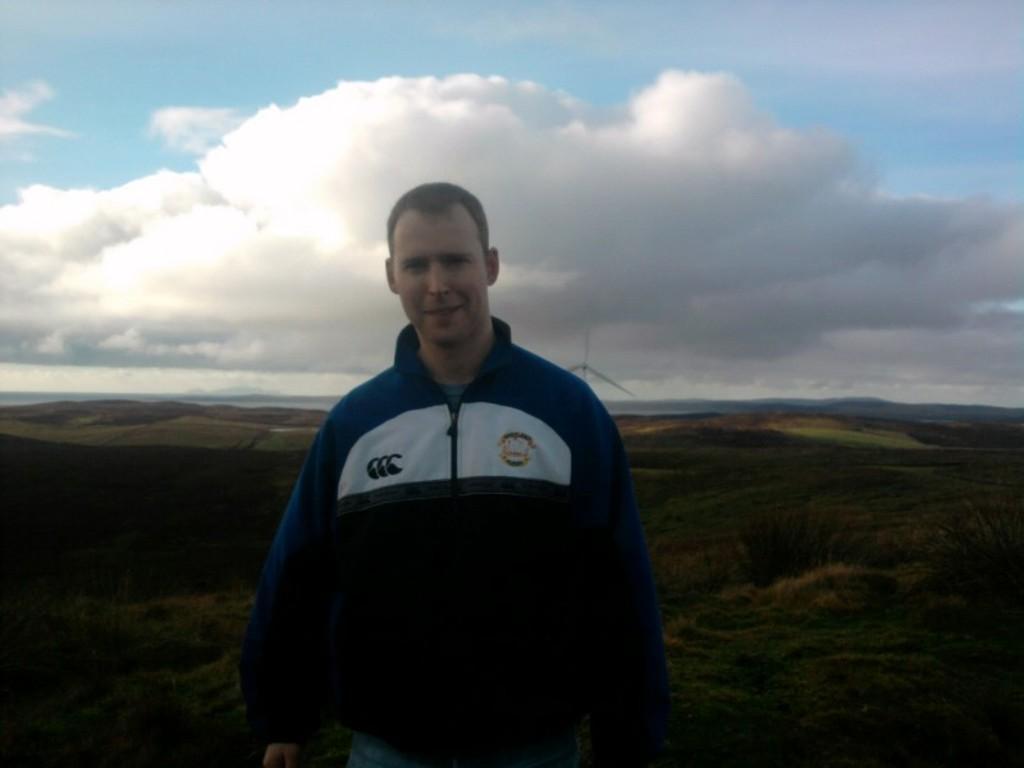Describe this image in one or two sentences. In this image, we can see a person is watching and smiling. Background we can see plants, grass, hills, windmill and cloudy sky. 